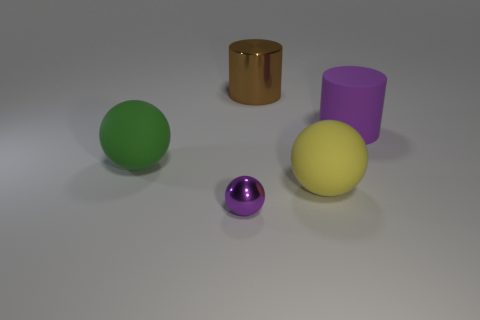Is there anything else that has the same color as the big shiny cylinder?
Keep it short and to the point. No. There is a cylinder that is on the right side of the large brown thing behind the tiny purple metallic sphere; what is its size?
Your answer should be very brief. Large. The big thing that is on the left side of the yellow matte ball and on the right side of the small purple thing is what color?
Provide a succinct answer. Brown. How many other things are there of the same size as the purple matte thing?
Provide a short and direct response. 3. There is a yellow thing; is it the same size as the metal thing in front of the big brown object?
Your answer should be compact. No. There is a matte cylinder that is the same size as the brown metal object; what color is it?
Keep it short and to the point. Purple. The green object is what size?
Give a very brief answer. Large. Is the material of the purple thing in front of the yellow rubber sphere the same as the green ball?
Your answer should be very brief. No. Is the purple rubber thing the same shape as the brown object?
Offer a very short reply. Yes. What is the shape of the purple object on the left side of the rubber sphere right of the metallic thing that is behind the large matte cylinder?
Make the answer very short. Sphere. 